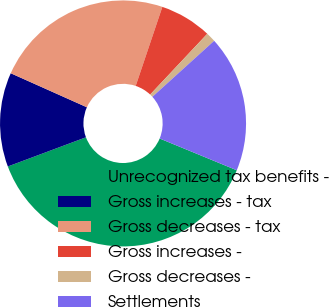Convert chart to OTSL. <chart><loc_0><loc_0><loc_500><loc_500><pie_chart><fcel>Unrecognized tax benefits -<fcel>Gross increases - tax<fcel>Gross decreases - tax<fcel>Gross increases -<fcel>Gross decreases -<fcel>Settlements<nl><fcel>38.09%<fcel>12.38%<fcel>23.49%<fcel>6.83%<fcel>1.27%<fcel>17.94%<nl></chart> 